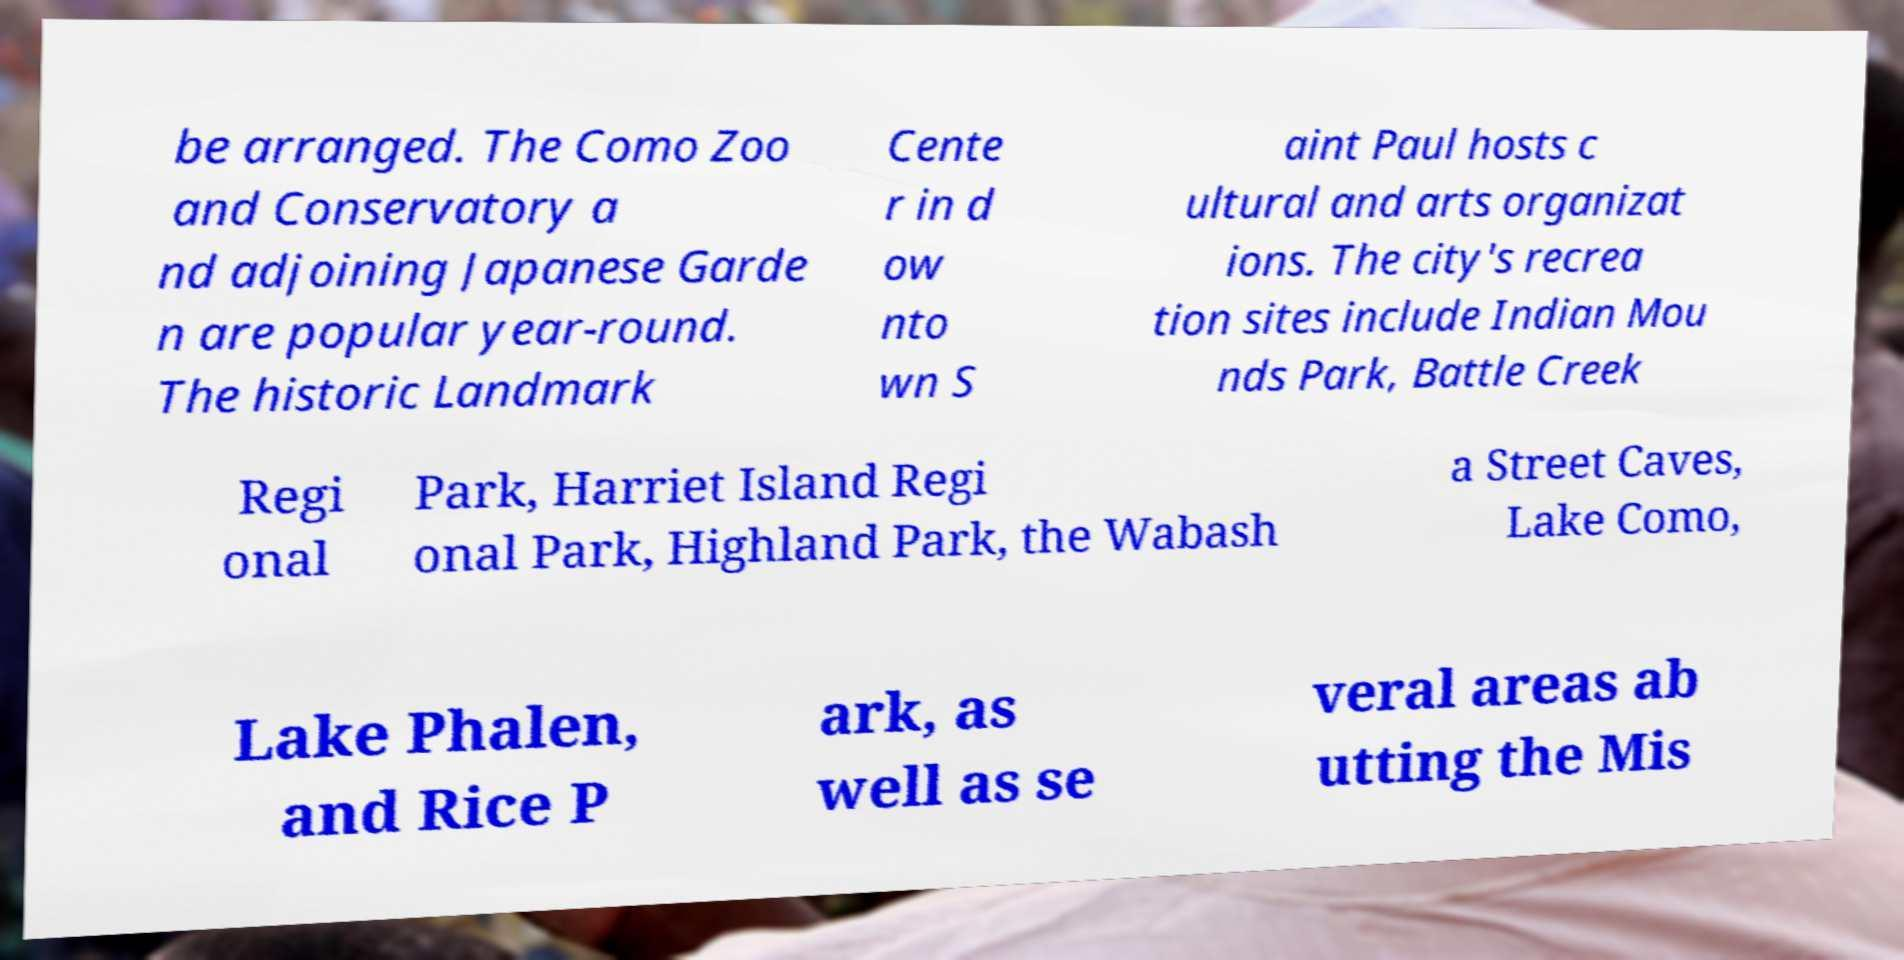I need the written content from this picture converted into text. Can you do that? be arranged. The Como Zoo and Conservatory a nd adjoining Japanese Garde n are popular year-round. The historic Landmark Cente r in d ow nto wn S aint Paul hosts c ultural and arts organizat ions. The city's recrea tion sites include Indian Mou nds Park, Battle Creek Regi onal Park, Harriet Island Regi onal Park, Highland Park, the Wabash a Street Caves, Lake Como, Lake Phalen, and Rice P ark, as well as se veral areas ab utting the Mis 